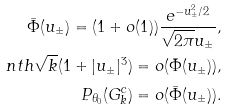<formula> <loc_0><loc_0><loc_500><loc_500>\bar { \Phi } ( u _ { \pm } ) = ( 1 + o ( 1 ) ) \frac { e ^ { - u ^ { 2 } _ { \pm } / 2 } } { \sqrt { 2 \pi } u _ { \pm } } , \\ \ n t h { \sqrt { k } ( 1 + | u _ { \pm } | ^ { 3 } ) } = o ( \bar { \Phi } ( u _ { \pm } ) ) , \\ P _ { \theta _ { 0 } } ( G _ { k } ^ { c } ) = o ( \bar { \Phi } ( u _ { \pm } ) ) .</formula> 